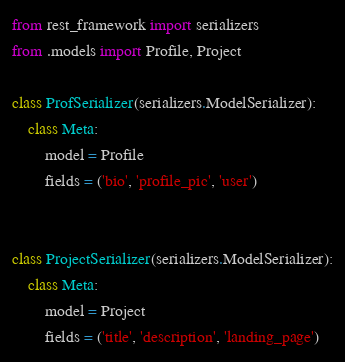Convert code to text. <code><loc_0><loc_0><loc_500><loc_500><_Python_>from rest_framework import serializers
from .models import Profile, Project

class ProfSerializer(serializers.ModelSerializer):
    class Meta:
        model = Profile
        fields = ('bio', 'profile_pic', 'user')


class ProjectSerializer(serializers.ModelSerializer):
    class Meta:
        model = Project
        fields = ('title', 'description', 'landing_page')


</code> 